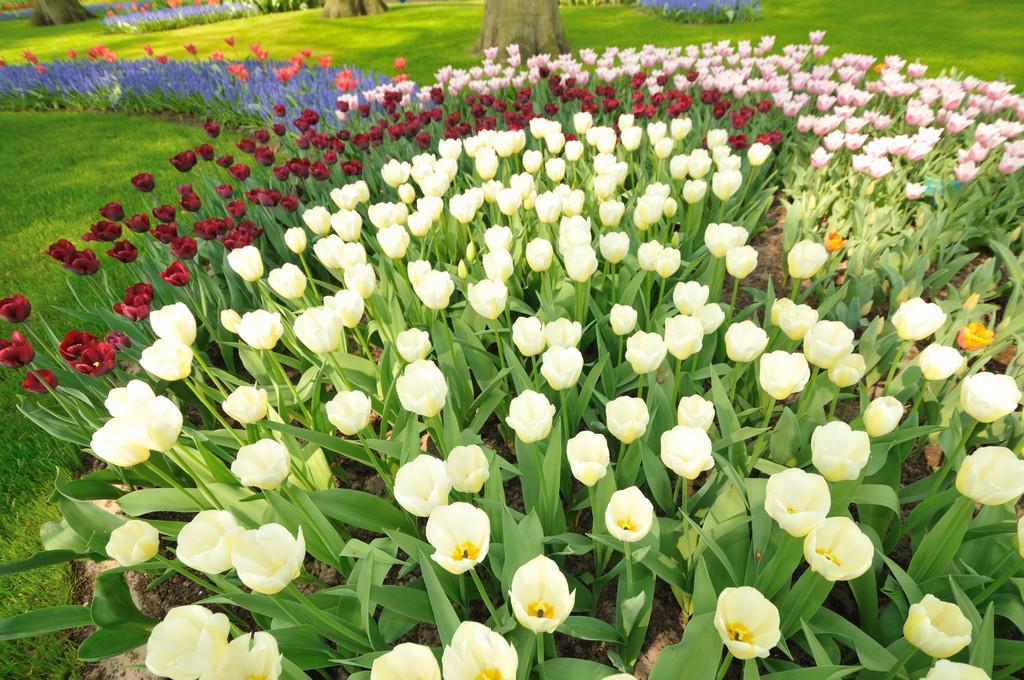In one or two sentences, can you explain what this image depicts? In the center of the image we can see plants and flowers. At the top of the image we can see trees. In the background of the image we can see the grass. 